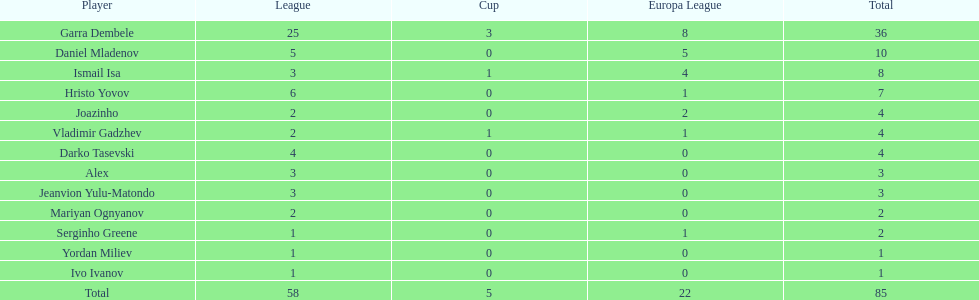Who are the players that scored only one goal? Serginho Greene, Yordan Miliev, Ivo Ivanov. 